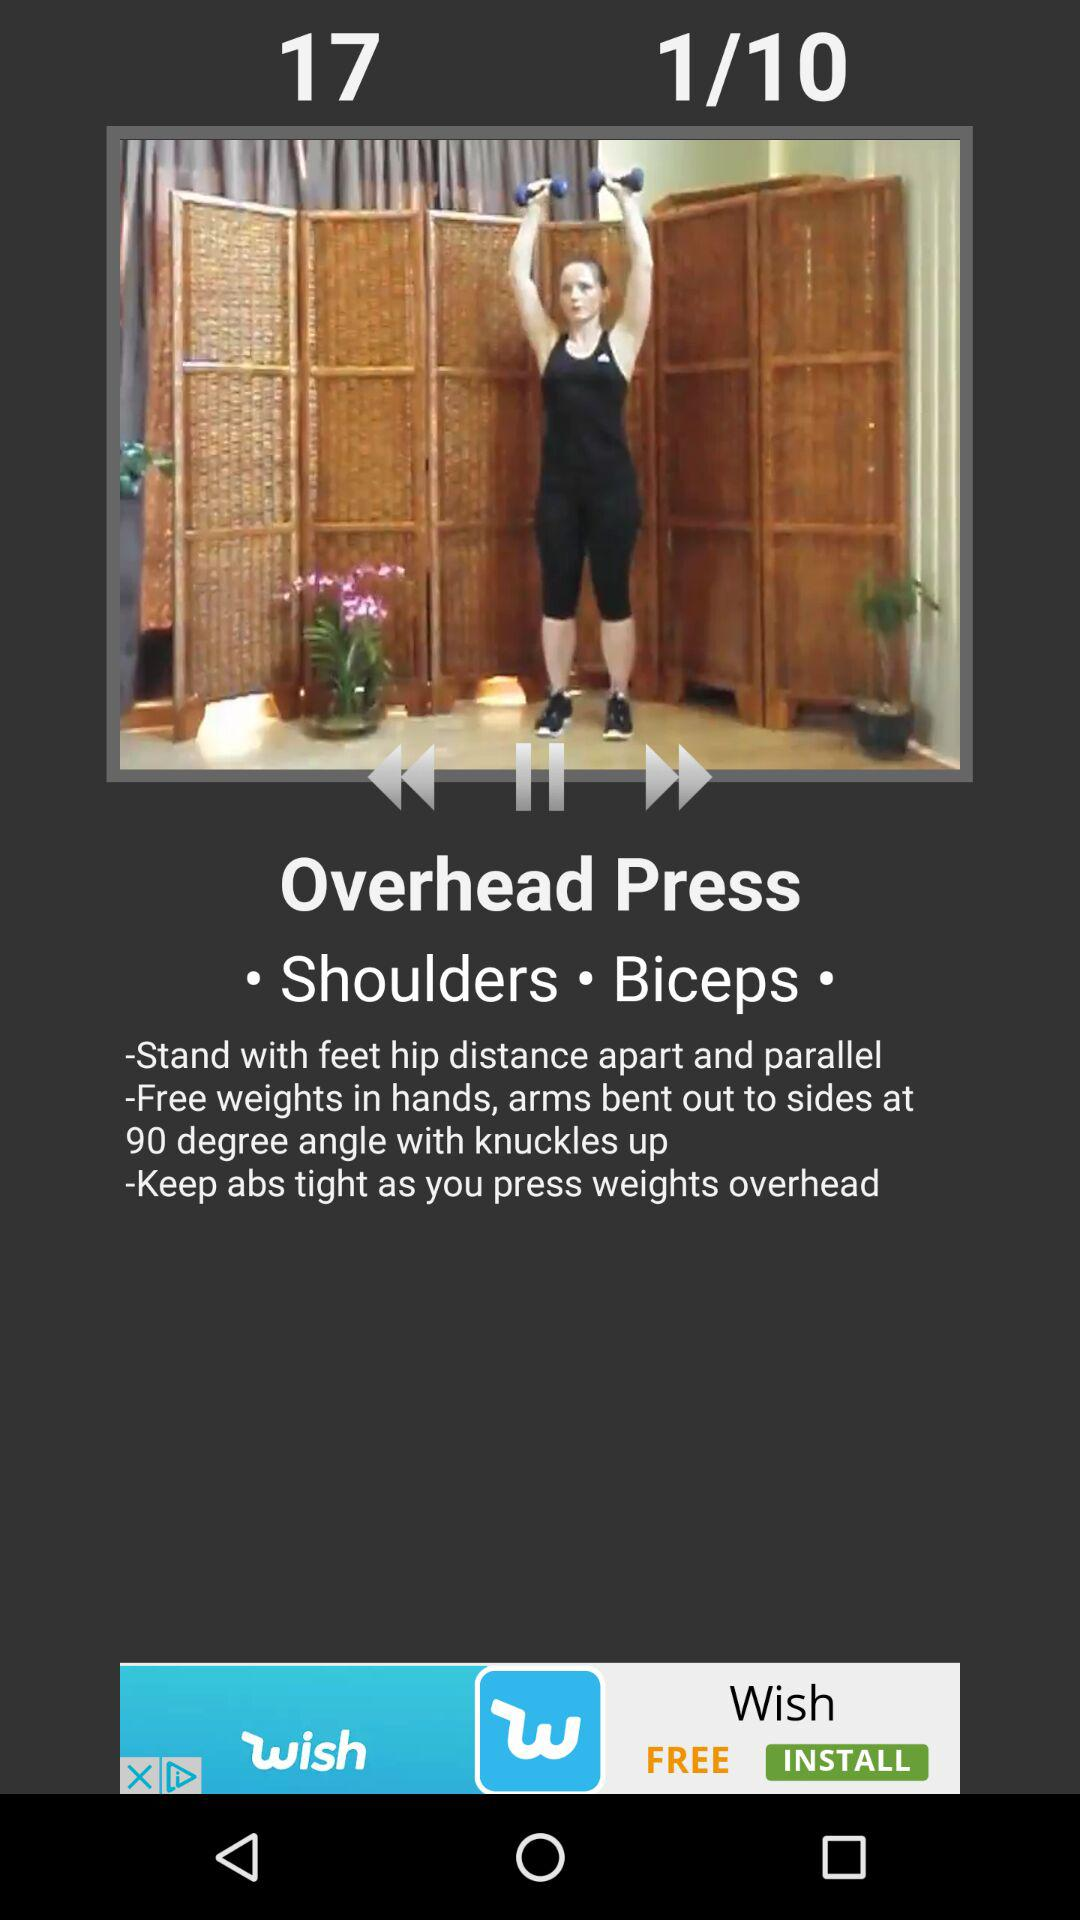How many muscles does this exercise target?
Answer the question using a single word or phrase. 2 